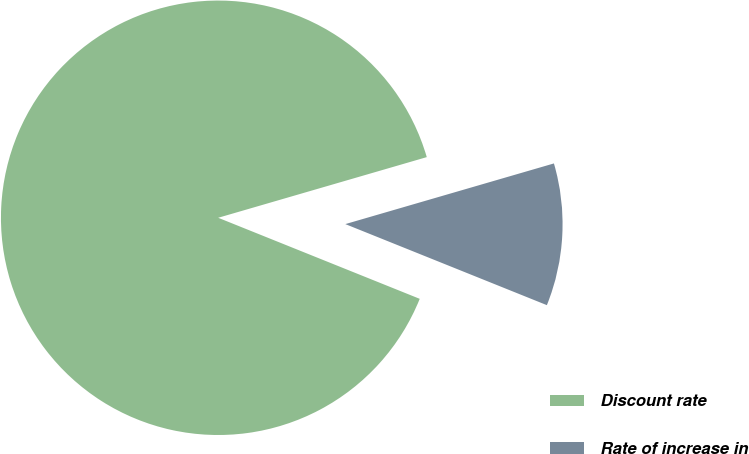Convert chart. <chart><loc_0><loc_0><loc_500><loc_500><pie_chart><fcel>Discount rate<fcel>Rate of increase in<nl><fcel>89.41%<fcel>10.59%<nl></chart> 